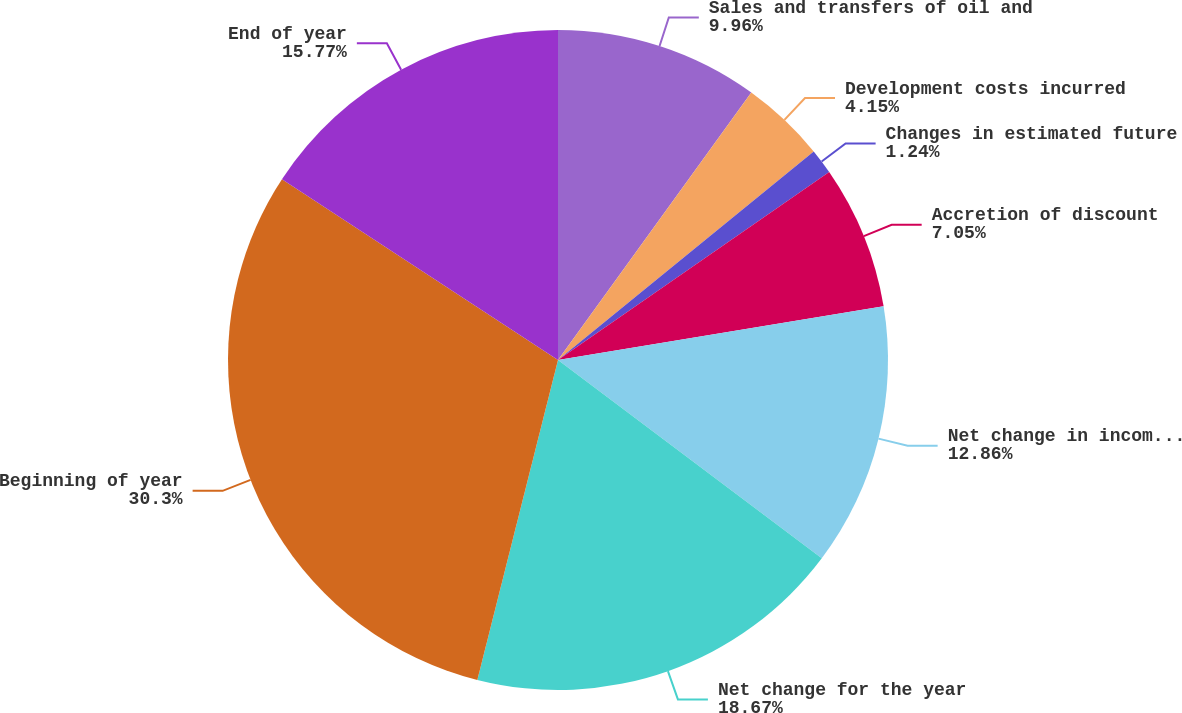Convert chart to OTSL. <chart><loc_0><loc_0><loc_500><loc_500><pie_chart><fcel>Sales and transfers of oil and<fcel>Development costs incurred<fcel>Changes in estimated future<fcel>Accretion of discount<fcel>Net change in income taxes<fcel>Net change for the year<fcel>Beginning of year<fcel>End of year<nl><fcel>9.96%<fcel>4.15%<fcel>1.24%<fcel>7.05%<fcel>12.86%<fcel>18.67%<fcel>30.3%<fcel>15.77%<nl></chart> 